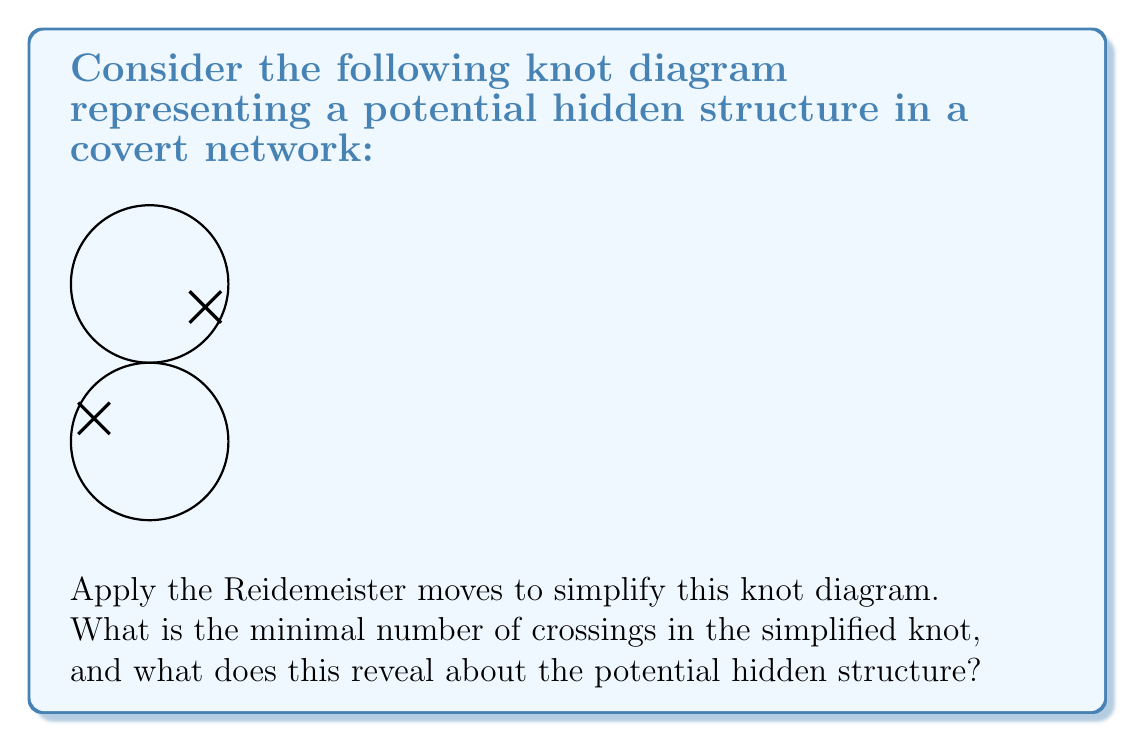What is the answer to this math problem? To simplify the given knot diagram and reveal potential hidden structures, we'll apply the Reidemeister moves systematically:

1. Analyze the initial diagram:
   - The diagram shows a knot with 4 crossings.
   - It appears to be a figure-eight knot, which is known to be non-trivial.

2. Apply Reidemeister moves:
   - Reidemeister move I (twist/untwist): Not applicable here as there are no obvious twists.
   - Reidemeister move II (push/pull): Not applicable as there are no parallel strands that can be separated.
   - Reidemeister move III (slide): Not applicable as there are no triangular regions formed by three strands.

3. Conclusion on simplification:
   - The knot cannot be simplified further using Reidemeister moves.
   - The minimal number of crossings remains 4.

4. Interpretation for counterintelligence:
   - The figure-eight knot is the simplest non-trivial knot.
   - In the context of a covert network, this suggests:
     a) The network has a complex structure that cannot be easily unraveled.
     b) There are at least four key connection points or agents in the network.
     c) The network is likely resilient to the removal of any single connection or agent.

5. Hidden structure revealed:
   - The knot's persistence under simplification attempts indicates a robust and well-designed covert network.
   - The figure-eight structure suggests a cyclic flow of information or resources, possibly with redundant pathways.
   - The four crossings may represent critical junctions or decision points in the network's operations.

In conclusion, the minimal number of crossings (4) and the knot's resistance to simplification reveal a non-trivial, resilient structure in the potential covert network, requiring sophisticated counterintelligence strategies for neutralization.
Answer: 4 crossings; reveals a resilient, non-trivial network structure 